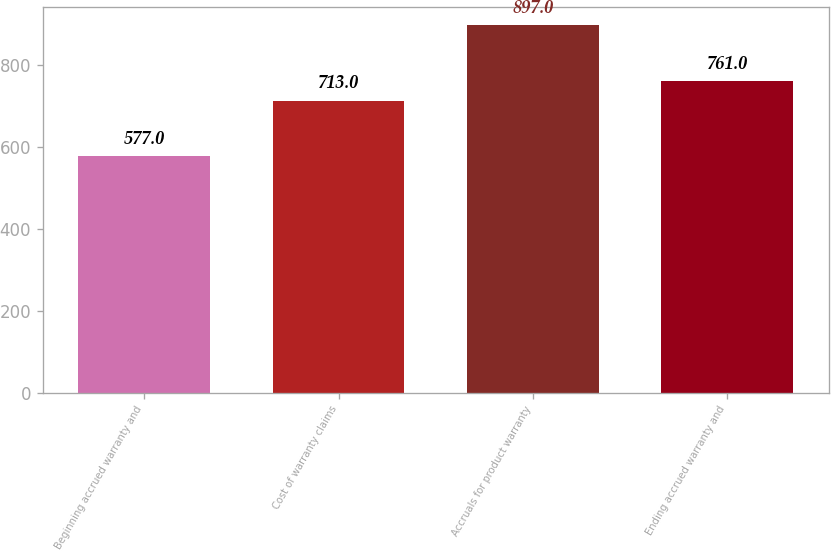Convert chart to OTSL. <chart><loc_0><loc_0><loc_500><loc_500><bar_chart><fcel>Beginning accrued warranty and<fcel>Cost of warranty claims<fcel>Accruals for product warranty<fcel>Ending accrued warranty and<nl><fcel>577<fcel>713<fcel>897<fcel>761<nl></chart> 